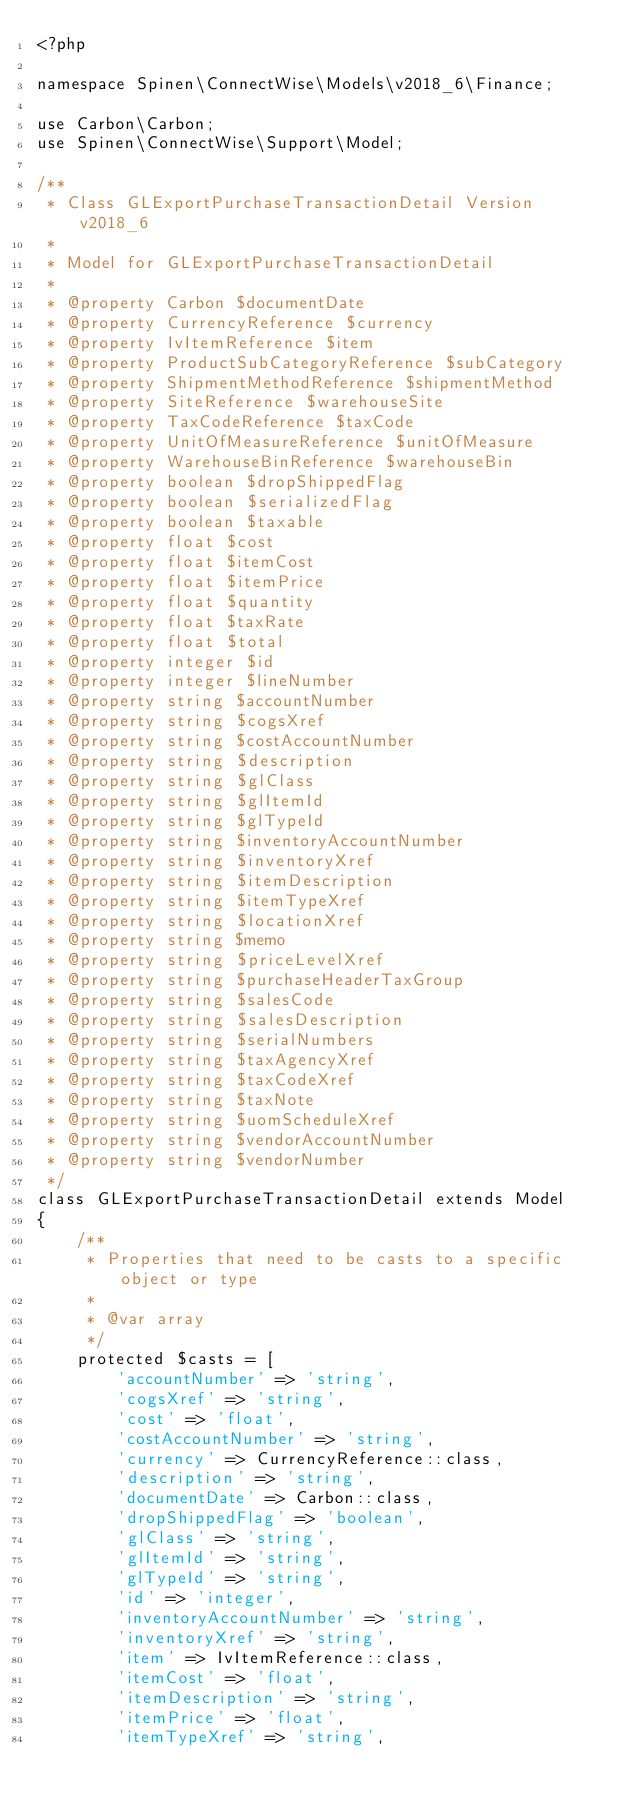Convert code to text. <code><loc_0><loc_0><loc_500><loc_500><_PHP_><?php

namespace Spinen\ConnectWise\Models\v2018_6\Finance;

use Carbon\Carbon;
use Spinen\ConnectWise\Support\Model;

/**
 * Class GLExportPurchaseTransactionDetail Version v2018_6
 *
 * Model for GLExportPurchaseTransactionDetail
 *
 * @property Carbon $documentDate
 * @property CurrencyReference $currency
 * @property IvItemReference $item
 * @property ProductSubCategoryReference $subCategory
 * @property ShipmentMethodReference $shipmentMethod
 * @property SiteReference $warehouseSite
 * @property TaxCodeReference $taxCode
 * @property UnitOfMeasureReference $unitOfMeasure
 * @property WarehouseBinReference $warehouseBin
 * @property boolean $dropShippedFlag
 * @property boolean $serializedFlag
 * @property boolean $taxable
 * @property float $cost
 * @property float $itemCost
 * @property float $itemPrice
 * @property float $quantity
 * @property float $taxRate
 * @property float $total
 * @property integer $id
 * @property integer $lineNumber
 * @property string $accountNumber
 * @property string $cogsXref
 * @property string $costAccountNumber
 * @property string $description
 * @property string $glClass
 * @property string $glItemId
 * @property string $glTypeId
 * @property string $inventoryAccountNumber
 * @property string $inventoryXref
 * @property string $itemDescription
 * @property string $itemTypeXref
 * @property string $locationXref
 * @property string $memo
 * @property string $priceLevelXref
 * @property string $purchaseHeaderTaxGroup
 * @property string $salesCode
 * @property string $salesDescription
 * @property string $serialNumbers
 * @property string $taxAgencyXref
 * @property string $taxCodeXref
 * @property string $taxNote
 * @property string $uomScheduleXref
 * @property string $vendorAccountNumber
 * @property string $vendorNumber
 */
class GLExportPurchaseTransactionDetail extends Model
{
    /**
     * Properties that need to be casts to a specific object or type
     *
     * @var array
     */
    protected $casts = [
        'accountNumber' => 'string',
        'cogsXref' => 'string',
        'cost' => 'float',
        'costAccountNumber' => 'string',
        'currency' => CurrencyReference::class,
        'description' => 'string',
        'documentDate' => Carbon::class,
        'dropShippedFlag' => 'boolean',
        'glClass' => 'string',
        'glItemId' => 'string',
        'glTypeId' => 'string',
        'id' => 'integer',
        'inventoryAccountNumber' => 'string',
        'inventoryXref' => 'string',
        'item' => IvItemReference::class,
        'itemCost' => 'float',
        'itemDescription' => 'string',
        'itemPrice' => 'float',
        'itemTypeXref' => 'string',</code> 